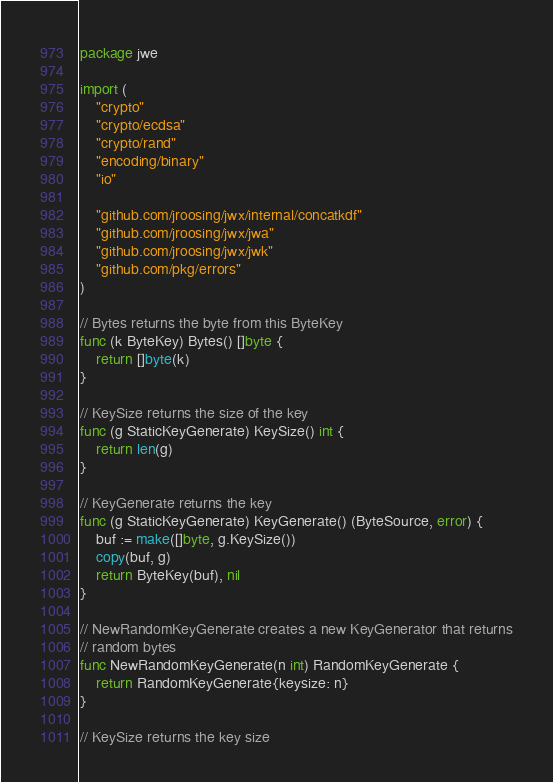<code> <loc_0><loc_0><loc_500><loc_500><_Go_>package jwe

import (
	"crypto"
	"crypto/ecdsa"
	"crypto/rand"
	"encoding/binary"
	"io"

	"github.com/jroosing/jwx/internal/concatkdf"
	"github.com/jroosing/jwx/jwa"
	"github.com/jroosing/jwx/jwk"
	"github.com/pkg/errors"
)

// Bytes returns the byte from this ByteKey
func (k ByteKey) Bytes() []byte {
	return []byte(k)
}

// KeySize returns the size of the key
func (g StaticKeyGenerate) KeySize() int {
	return len(g)
}

// KeyGenerate returns the key
func (g StaticKeyGenerate) KeyGenerate() (ByteSource, error) {
	buf := make([]byte, g.KeySize())
	copy(buf, g)
	return ByteKey(buf), nil
}

// NewRandomKeyGenerate creates a new KeyGenerator that returns
// random bytes
func NewRandomKeyGenerate(n int) RandomKeyGenerate {
	return RandomKeyGenerate{keysize: n}
}

// KeySize returns the key size</code> 